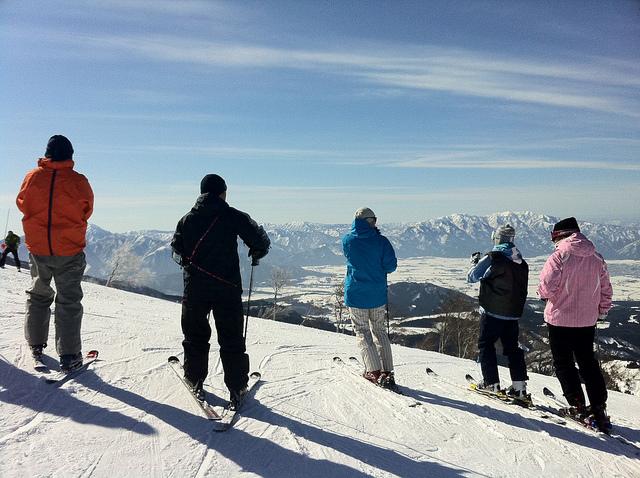How many people are standing on the hill?
Keep it brief. 5. What direction does the trail take just ahead?
Keep it brief. Down. What is the color of the woman's coat who is standing on the far right?
Be succinct. Pink. What are the people standing on?
Answer briefly. Skis. 